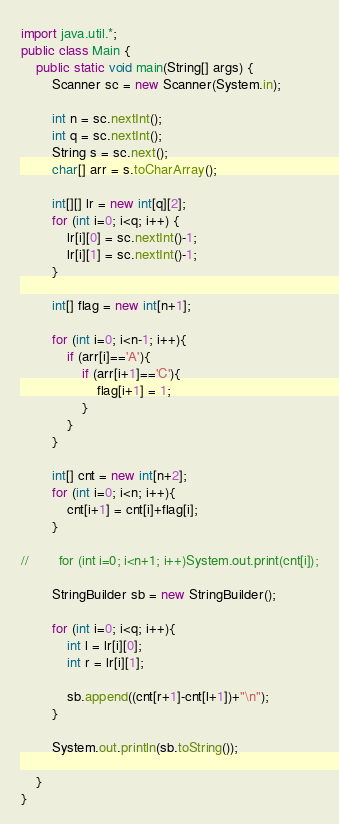Convert code to text. <code><loc_0><loc_0><loc_500><loc_500><_Java_>import java.util.*;
public class Main {
    public static void main(String[] args) {
        Scanner sc = new Scanner(System.in);

        int n = sc.nextInt();
        int q = sc.nextInt();
        String s = sc.next();
        char[] arr = s.toCharArray();

        int[][] lr = new int[q][2];
        for (int i=0; i<q; i++) {
            lr[i][0] = sc.nextInt()-1;
            lr[i][1] = sc.nextInt()-1;
        }

        int[] flag = new int[n+1];

        for (int i=0; i<n-1; i++){
            if (arr[i]=='A'){
                if (arr[i+1]=='C'){
                    flag[i+1] = 1;
                }
            }
        }

        int[] cnt = new int[n+2];
        for (int i=0; i<n; i++){
            cnt[i+1] = cnt[i]+flag[i];
        }

//        for (int i=0; i<n+1; i++)System.out.print(cnt[i]);

        StringBuilder sb = new StringBuilder();

        for (int i=0; i<q; i++){
            int l = lr[i][0];
            int r = lr[i][1];

            sb.append((cnt[r+1]-cnt[l+1])+"\n");
        }

        System.out.println(sb.toString());

    }
}
</code> 